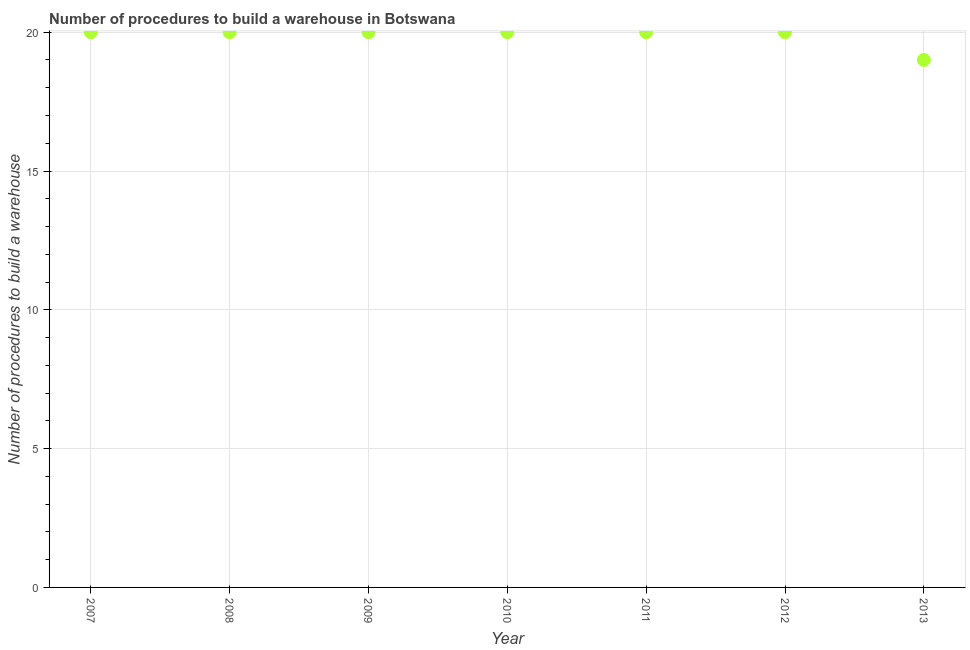What is the number of procedures to build a warehouse in 2009?
Ensure brevity in your answer.  20. Across all years, what is the maximum number of procedures to build a warehouse?
Offer a very short reply. 20. Across all years, what is the minimum number of procedures to build a warehouse?
Keep it short and to the point. 19. What is the sum of the number of procedures to build a warehouse?
Provide a succinct answer. 139. What is the difference between the number of procedures to build a warehouse in 2008 and 2009?
Provide a succinct answer. 0. What is the average number of procedures to build a warehouse per year?
Offer a very short reply. 19.86. What is the median number of procedures to build a warehouse?
Ensure brevity in your answer.  20. In how many years, is the number of procedures to build a warehouse greater than 14 ?
Your answer should be very brief. 7. What is the ratio of the number of procedures to build a warehouse in 2007 to that in 2008?
Your response must be concise. 1. Is the difference between the number of procedures to build a warehouse in 2007 and 2009 greater than the difference between any two years?
Make the answer very short. No. Is the sum of the number of procedures to build a warehouse in 2009 and 2013 greater than the maximum number of procedures to build a warehouse across all years?
Your answer should be very brief. Yes. What is the difference between the highest and the lowest number of procedures to build a warehouse?
Your response must be concise. 1. Does the number of procedures to build a warehouse monotonically increase over the years?
Offer a terse response. No. How many years are there in the graph?
Provide a short and direct response. 7. What is the difference between two consecutive major ticks on the Y-axis?
Offer a terse response. 5. Are the values on the major ticks of Y-axis written in scientific E-notation?
Provide a short and direct response. No. Does the graph contain grids?
Your answer should be very brief. Yes. What is the title of the graph?
Your answer should be compact. Number of procedures to build a warehouse in Botswana. What is the label or title of the X-axis?
Offer a terse response. Year. What is the label or title of the Y-axis?
Your response must be concise. Number of procedures to build a warehouse. What is the Number of procedures to build a warehouse in 2009?
Your answer should be compact. 20. What is the Number of procedures to build a warehouse in 2013?
Make the answer very short. 19. What is the difference between the Number of procedures to build a warehouse in 2007 and 2010?
Make the answer very short. 0. What is the difference between the Number of procedures to build a warehouse in 2007 and 2011?
Make the answer very short. 0. What is the difference between the Number of procedures to build a warehouse in 2007 and 2012?
Your response must be concise. 0. What is the difference between the Number of procedures to build a warehouse in 2008 and 2009?
Make the answer very short. 0. What is the difference between the Number of procedures to build a warehouse in 2008 and 2010?
Your answer should be very brief. 0. What is the difference between the Number of procedures to build a warehouse in 2008 and 2012?
Give a very brief answer. 0. What is the difference between the Number of procedures to build a warehouse in 2008 and 2013?
Provide a succinct answer. 1. What is the difference between the Number of procedures to build a warehouse in 2009 and 2010?
Make the answer very short. 0. What is the difference between the Number of procedures to build a warehouse in 2009 and 2011?
Your answer should be compact. 0. What is the difference between the Number of procedures to build a warehouse in 2009 and 2012?
Your answer should be very brief. 0. What is the difference between the Number of procedures to build a warehouse in 2009 and 2013?
Offer a very short reply. 1. What is the difference between the Number of procedures to build a warehouse in 2010 and 2011?
Ensure brevity in your answer.  0. What is the difference between the Number of procedures to build a warehouse in 2011 and 2013?
Your answer should be very brief. 1. What is the difference between the Number of procedures to build a warehouse in 2012 and 2013?
Give a very brief answer. 1. What is the ratio of the Number of procedures to build a warehouse in 2007 to that in 2008?
Ensure brevity in your answer.  1. What is the ratio of the Number of procedures to build a warehouse in 2007 to that in 2010?
Give a very brief answer. 1. What is the ratio of the Number of procedures to build a warehouse in 2007 to that in 2011?
Give a very brief answer. 1. What is the ratio of the Number of procedures to build a warehouse in 2007 to that in 2013?
Keep it short and to the point. 1.05. What is the ratio of the Number of procedures to build a warehouse in 2008 to that in 2009?
Your response must be concise. 1. What is the ratio of the Number of procedures to build a warehouse in 2008 to that in 2011?
Give a very brief answer. 1. What is the ratio of the Number of procedures to build a warehouse in 2008 to that in 2012?
Your response must be concise. 1. What is the ratio of the Number of procedures to build a warehouse in 2008 to that in 2013?
Ensure brevity in your answer.  1.05. What is the ratio of the Number of procedures to build a warehouse in 2009 to that in 2011?
Ensure brevity in your answer.  1. What is the ratio of the Number of procedures to build a warehouse in 2009 to that in 2012?
Offer a terse response. 1. What is the ratio of the Number of procedures to build a warehouse in 2009 to that in 2013?
Give a very brief answer. 1.05. What is the ratio of the Number of procedures to build a warehouse in 2010 to that in 2011?
Ensure brevity in your answer.  1. What is the ratio of the Number of procedures to build a warehouse in 2010 to that in 2012?
Your response must be concise. 1. What is the ratio of the Number of procedures to build a warehouse in 2010 to that in 2013?
Offer a terse response. 1.05. What is the ratio of the Number of procedures to build a warehouse in 2011 to that in 2012?
Offer a terse response. 1. What is the ratio of the Number of procedures to build a warehouse in 2011 to that in 2013?
Offer a terse response. 1.05. What is the ratio of the Number of procedures to build a warehouse in 2012 to that in 2013?
Give a very brief answer. 1.05. 